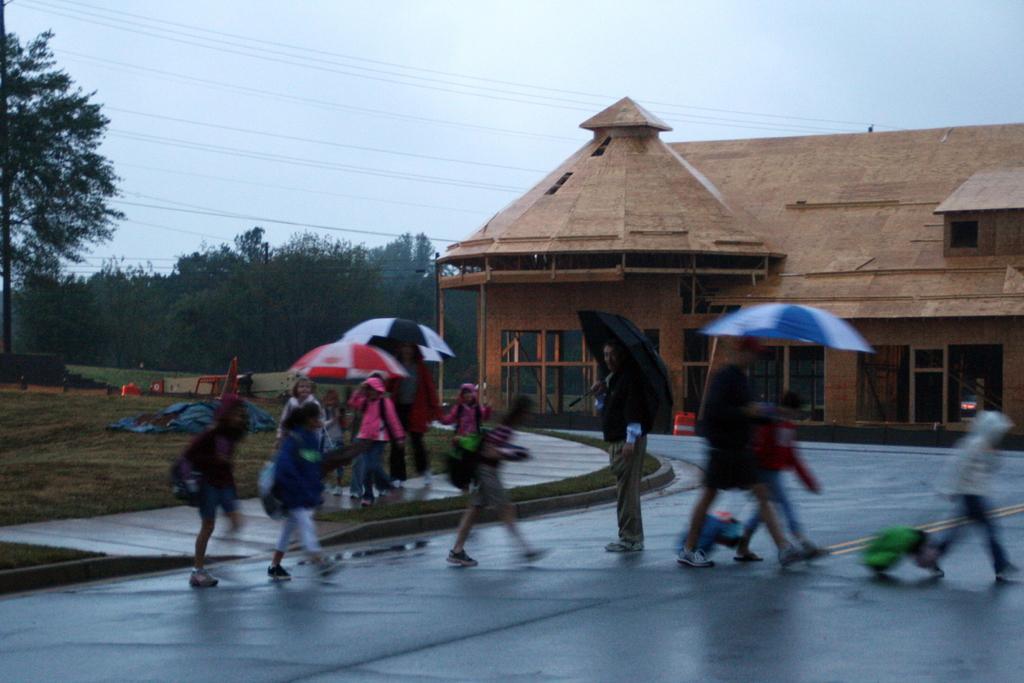Please provide a concise description of this image. In this picture I can see there are few kids crossing the road and there are few persons standing and they are holding umbrellas. There are trees at right side and there is a building in the backdrop. The sky is clear. 